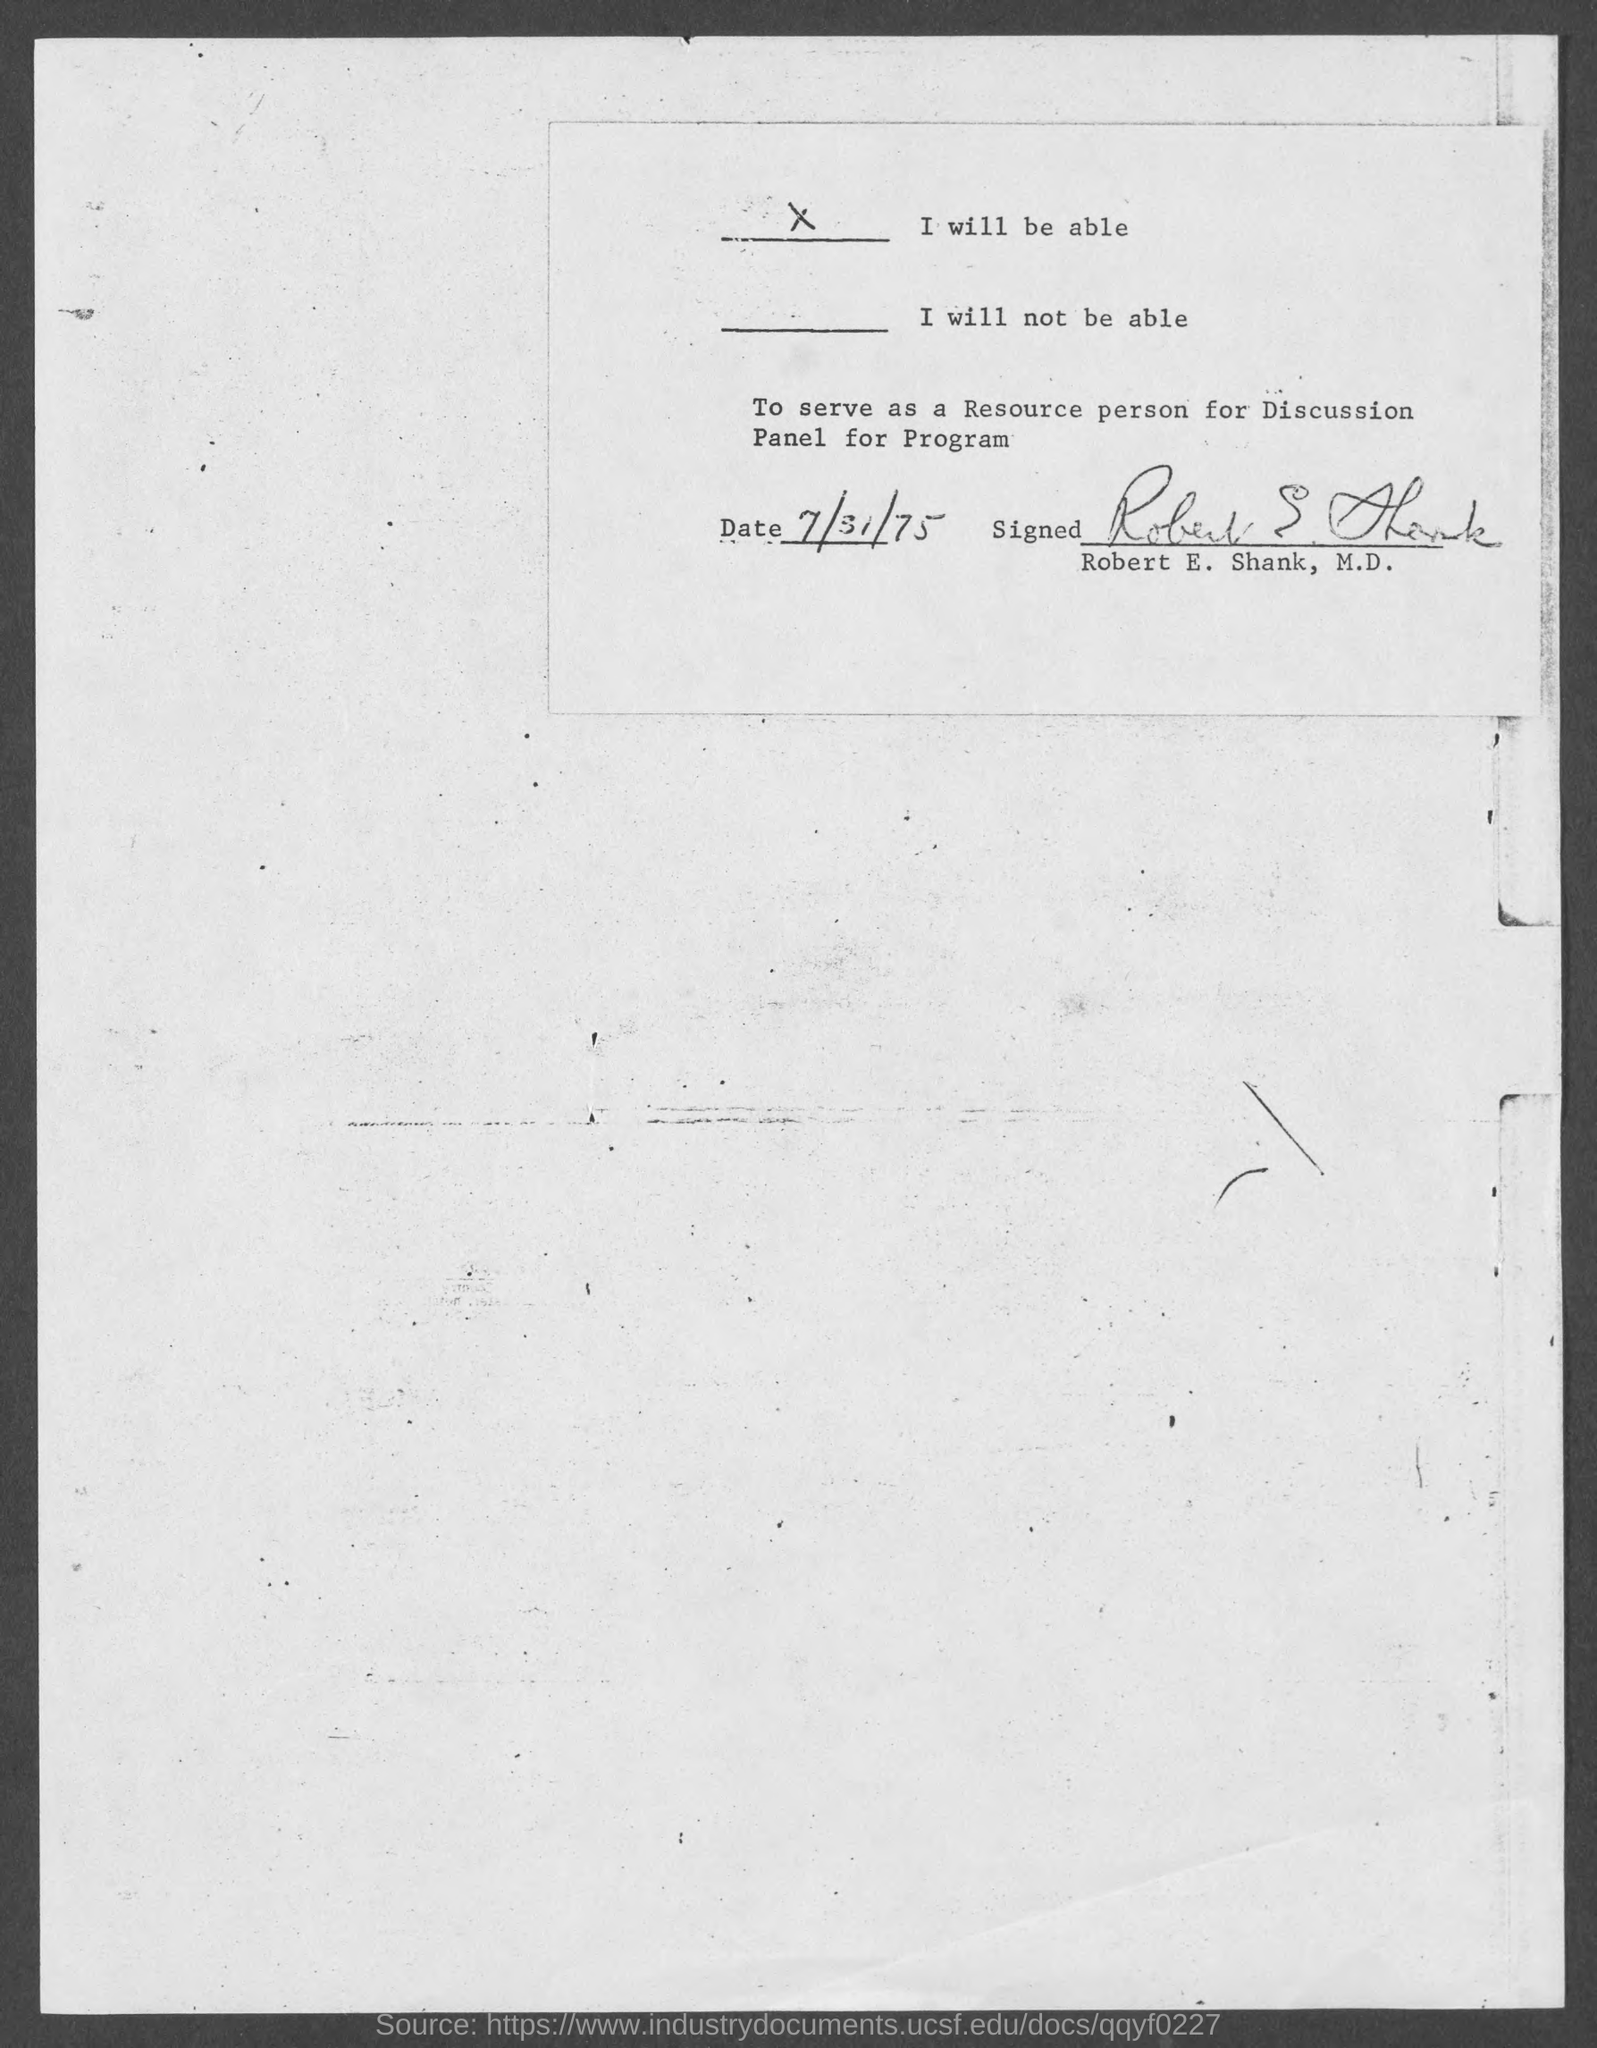Who signed to serve as a person for discussion panel for program?
Keep it short and to the point. Robert E. Shank. 